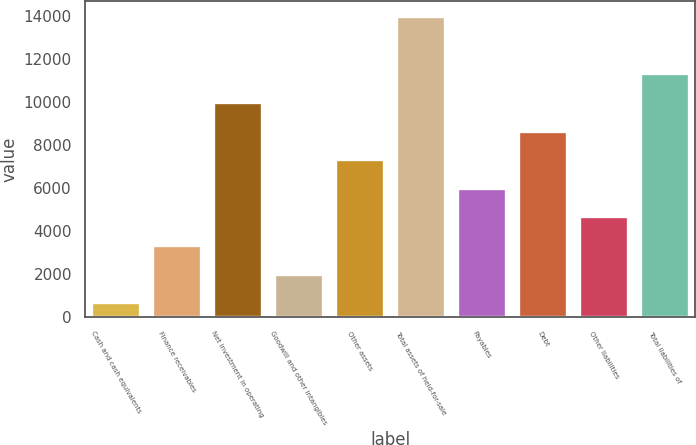Convert chart to OTSL. <chart><loc_0><loc_0><loc_500><loc_500><bar_chart><fcel>Cash and cash equivalents<fcel>Finance receivables<fcel>Net investment in operating<fcel>Goodwill and other intangibles<fcel>Other assets<fcel>Total assets of held-for-sale<fcel>Payables<fcel>Debt<fcel>Other liabilities<fcel>Total liabilities of<nl><fcel>679<fcel>3337.6<fcel>9984.1<fcel>2008.3<fcel>7325.5<fcel>13972<fcel>5996.2<fcel>8654.8<fcel>4666.9<fcel>11338<nl></chart> 